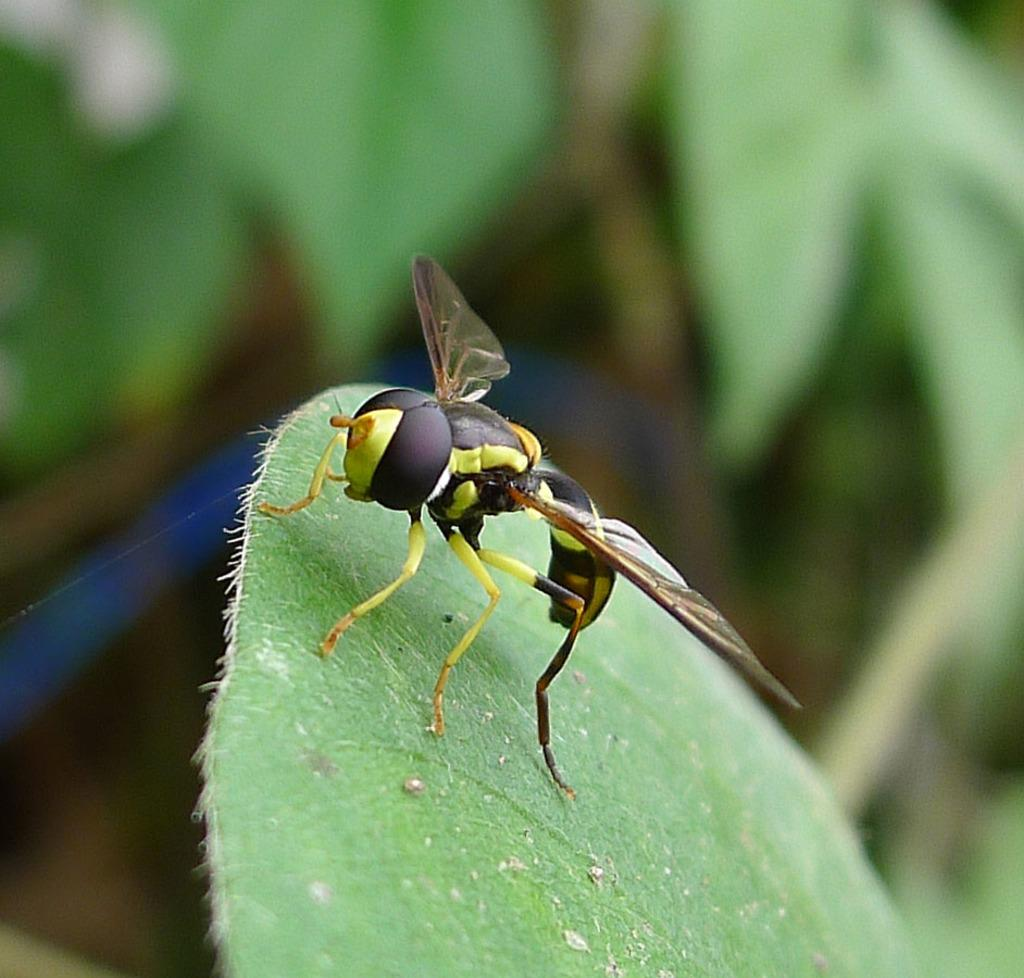What is on the leaf in the image? There is an insect on a leaf in the image. What can be seen in the background of the image? There is a group of plants in the background of the image. What type of roof can be seen on the insect's house in the image? There is no insect house or roof present in the image; it features an insect on a leaf and a group of plants in the background. 